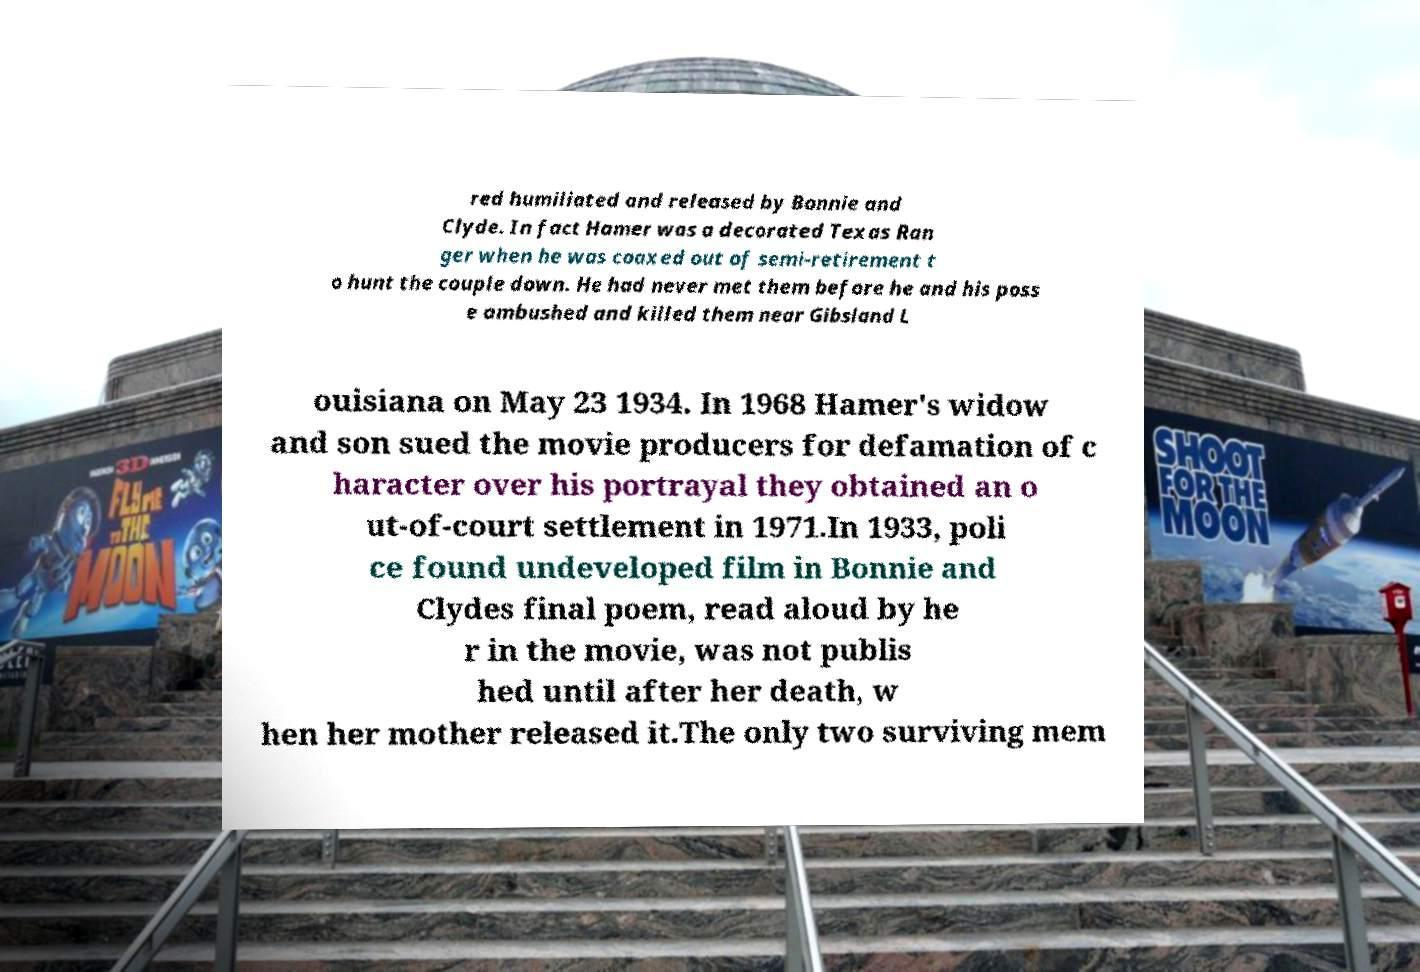What messages or text are displayed in this image? I need them in a readable, typed format. red humiliated and released by Bonnie and Clyde. In fact Hamer was a decorated Texas Ran ger when he was coaxed out of semi-retirement t o hunt the couple down. He had never met them before he and his poss e ambushed and killed them near Gibsland L ouisiana on May 23 1934. In 1968 Hamer's widow and son sued the movie producers for defamation of c haracter over his portrayal they obtained an o ut-of-court settlement in 1971.In 1933, poli ce found undeveloped film in Bonnie and Clydes final poem, read aloud by he r in the movie, was not publis hed until after her death, w hen her mother released it.The only two surviving mem 